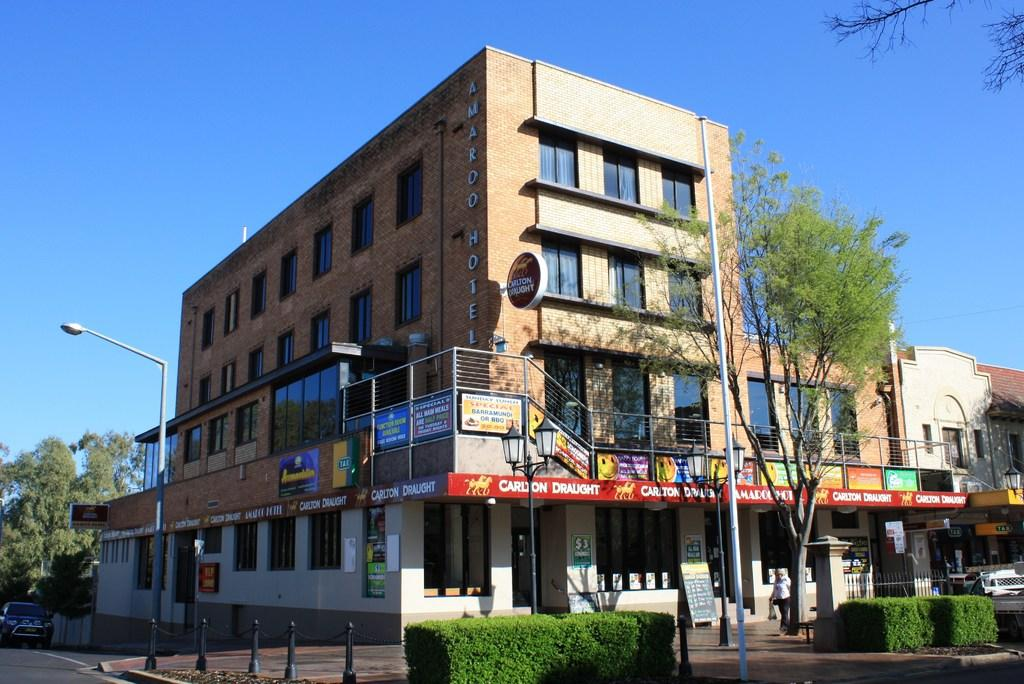What type of structures can be seen in the image? There are buildings in the image. What are the vertical objects in the image? There are poles in the image. What are the sources of illumination in the image? There are street lights in the image. What type of vegetation is present in the image? There are trees in the image. What part of the natural environment is visible in the image? The sky is visible in the image. What type of vehicle is on the road on the left side of the image? There is a car on the road on the left side of the image. Where are the poles located in the image? There are poles in the image and in the background of the image. What type of plants can be seen in the background of the image? There are plants in the background of the image. What type of sweater is the car wearing in the image? There is no sweater present in the image, as cars do not wear clothing. What appliance can be seen in the background of the image? There is no appliance visible in the image; the background features poles and plants. 